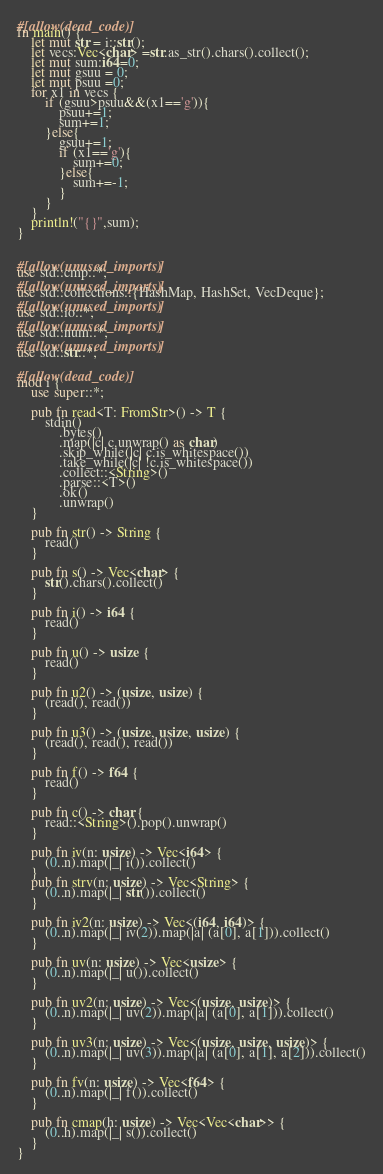<code> <loc_0><loc_0><loc_500><loc_500><_Rust_>#[allow(dead_code)]
fn main() {
    let mut str = i::str();
    let vecs:Vec<char> =str.as_str().chars().collect();
    let mut sum:i64=0;
    let mut gsuu = 0;
    let mut psuu =0;
    for x1 in vecs {
        if (gsuu>psuu&&(x1=='g')){
            psuu+=1;
            sum+=1;
        }else{
            gsuu+=1;
            if (x1=='g'){
                sum+=0;
            }else{
                sum+=-1;
            }
        }
    }
    println!("{}",sum);
}


#[allow(unused_imports)]
use std::cmp::*;
#[allow(unused_imports)]
use std::collections::{HashMap, HashSet, VecDeque};
#[allow(unused_imports)]
use std::io::*;
#[allow(unused_imports)]
use std::num::*;
#[allow(unused_imports)]
use std::str::*;

#[allow(dead_code)]
mod i {
    use super::*;

    pub fn read<T: FromStr>() -> T {
        stdin()
            .bytes()
            .map(|c| c.unwrap() as char)
            .skip_while(|c| c.is_whitespace())
            .take_while(|c| !c.is_whitespace())
            .collect::<String>()
            .parse::<T>()
            .ok()
            .unwrap()
    }

    pub fn str() -> String {
        read()
    }

    pub fn s() -> Vec<char> {
        str().chars().collect()
    }

    pub fn i() -> i64 {
        read()
    }

    pub fn u() -> usize {
        read()
    }

    pub fn u2() -> (usize, usize) {
        (read(), read())
    }

    pub fn u3() -> (usize, usize, usize) {
        (read(), read(), read())
    }

    pub fn f() -> f64 {
        read()
    }

    pub fn c() -> char {
        read::<String>().pop().unwrap()
    }

    pub fn iv(n: usize) -> Vec<i64> {
        (0..n).map(|_| i()).collect()
    }
    pub fn strv(n: usize) -> Vec<String> {
        (0..n).map(|_| str()).collect()
    }

    pub fn iv2(n: usize) -> Vec<(i64, i64)> {
        (0..n).map(|_| iv(2)).map(|a| (a[0], a[1])).collect()
    }

    pub fn uv(n: usize) -> Vec<usize> {
        (0..n).map(|_| u()).collect()
    }

    pub fn uv2(n: usize) -> Vec<(usize, usize)> {
        (0..n).map(|_| uv(2)).map(|a| (a[0], a[1])).collect()
    }

    pub fn uv3(n: usize) -> Vec<(usize, usize, usize)> {
        (0..n).map(|_| uv(3)).map(|a| (a[0], a[1], a[2])).collect()
    }

    pub fn fv(n: usize) -> Vec<f64> {
        (0..n).map(|_| f()).collect()
    }

    pub fn cmap(h: usize) -> Vec<Vec<char>> {
        (0..h).map(|_| s()).collect()
    }
}
</code> 